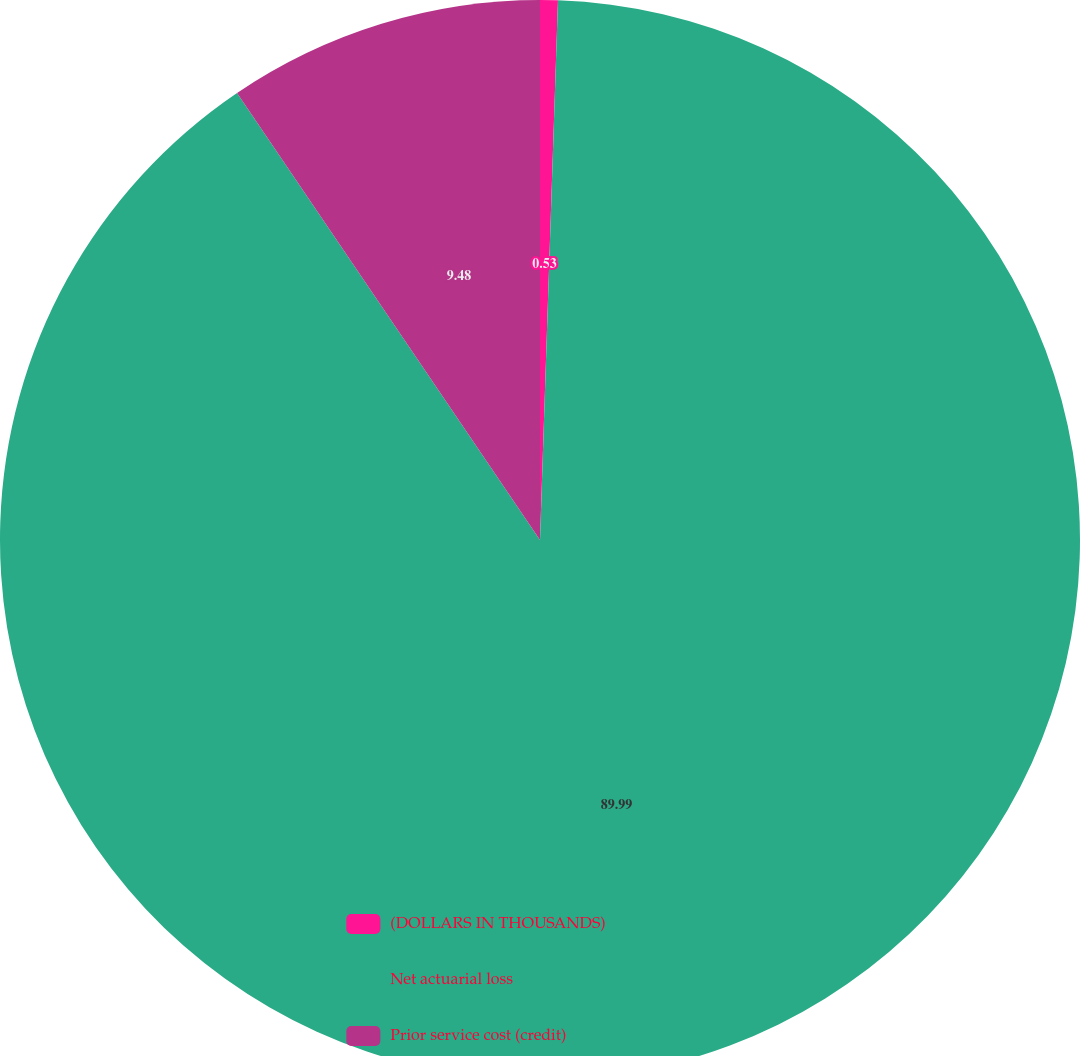Convert chart to OTSL. <chart><loc_0><loc_0><loc_500><loc_500><pie_chart><fcel>(DOLLARS IN THOUSANDS)<fcel>Net actuarial loss<fcel>Prior service cost (credit)<nl><fcel>0.53%<fcel>89.99%<fcel>9.48%<nl></chart> 